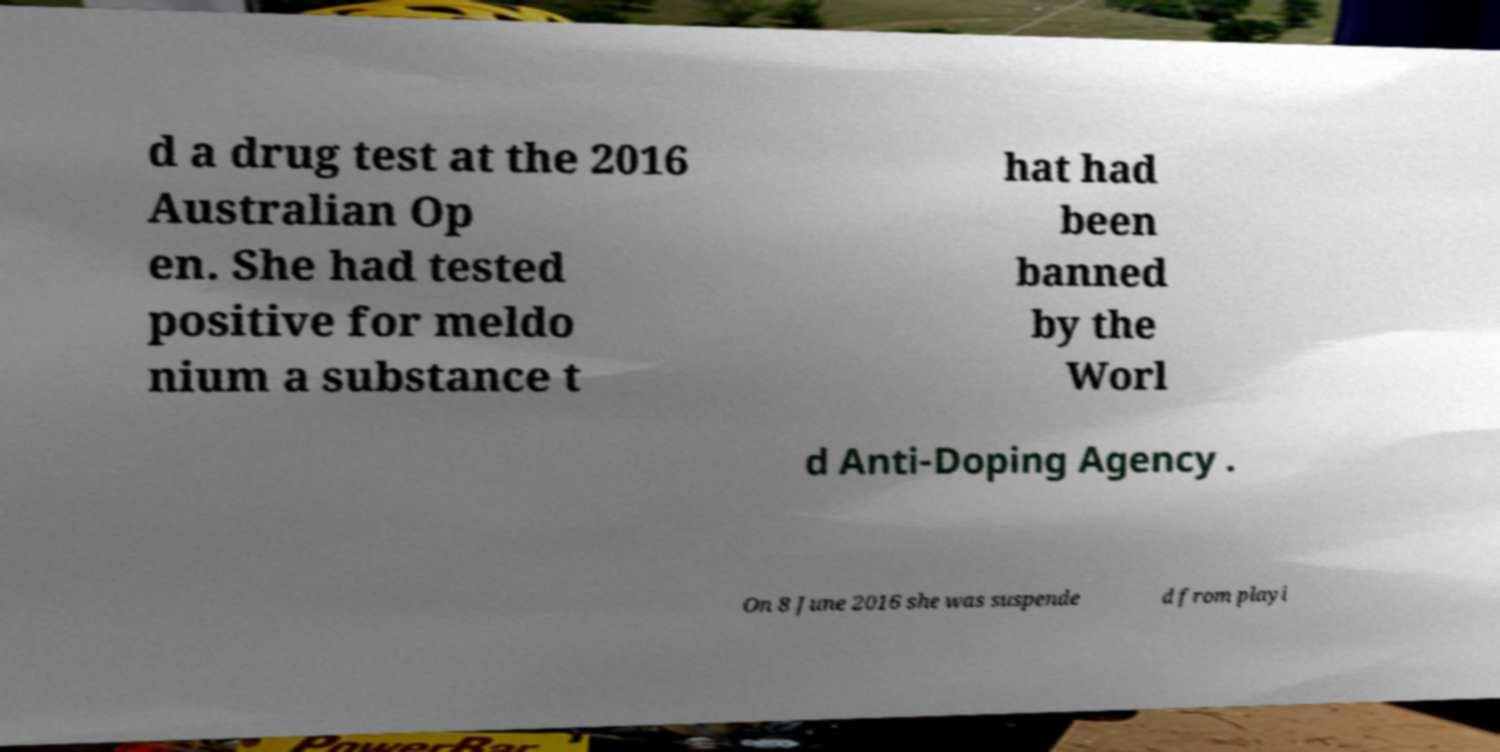Please identify and transcribe the text found in this image. d a drug test at the 2016 Australian Op en. She had tested positive for meldo nium a substance t hat had been banned by the Worl d Anti-Doping Agency . On 8 June 2016 she was suspende d from playi 